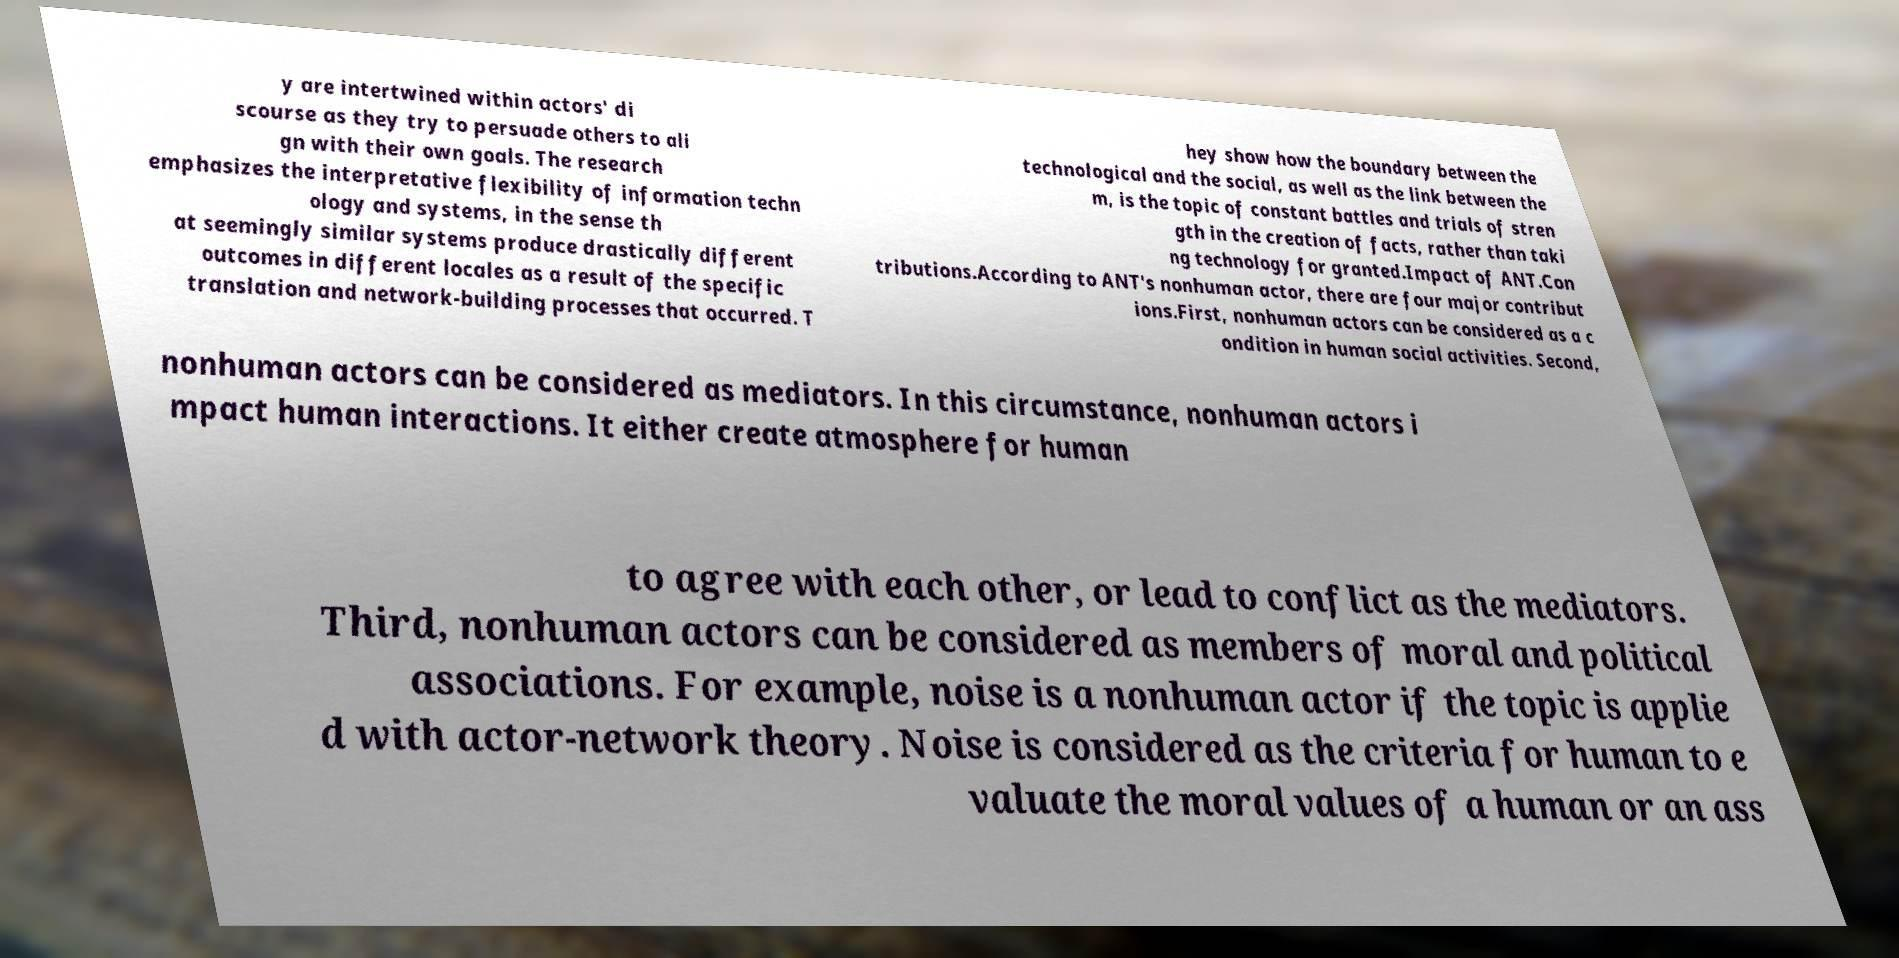Could you extract and type out the text from this image? y are intertwined within actors' di scourse as they try to persuade others to ali gn with their own goals. The research emphasizes the interpretative flexibility of information techn ology and systems, in the sense th at seemingly similar systems produce drastically different outcomes in different locales as a result of the specific translation and network-building processes that occurred. T hey show how the boundary between the technological and the social, as well as the link between the m, is the topic of constant battles and trials of stren gth in the creation of facts, rather than taki ng technology for granted.Impact of ANT.Con tributions.According to ANT's nonhuman actor, there are four major contribut ions.First, nonhuman actors can be considered as a c ondition in human social activities. Second, nonhuman actors can be considered as mediators. In this circumstance, nonhuman actors i mpact human interactions. It either create atmosphere for human to agree with each other, or lead to conflict as the mediators. Third, nonhuman actors can be considered as members of moral and political associations. For example, noise is a nonhuman actor if the topic is applie d with actor-network theory. Noise is considered as the criteria for human to e valuate the moral values of a human or an ass 